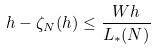Convert formula to latex. <formula><loc_0><loc_0><loc_500><loc_500>h - \zeta _ { N } ( h ) \leq \frac { W h } { L _ { * } ( N ) }</formula> 